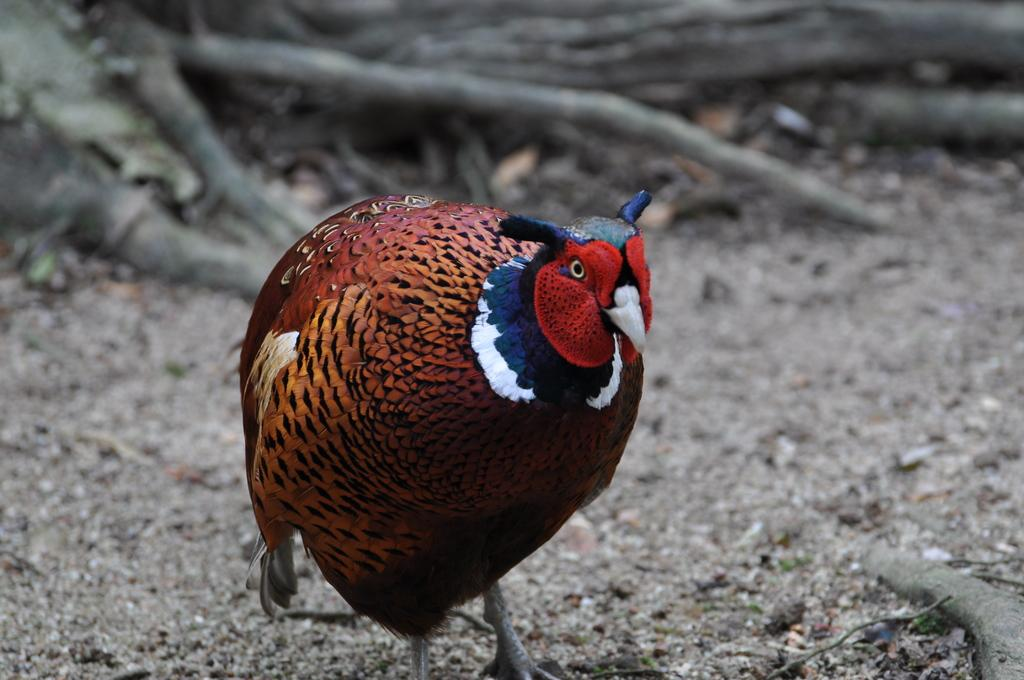What is the main subject of the image? There is a bird in the center of the image. Can you describe the bird's appearance? The bird has brown and red colors. What can be seen in the background of the image? There are woods in the background of the image. What decision did the writer make in the image? There is no writer or decision-making process depicted in the image; it features a bird in the woods. 